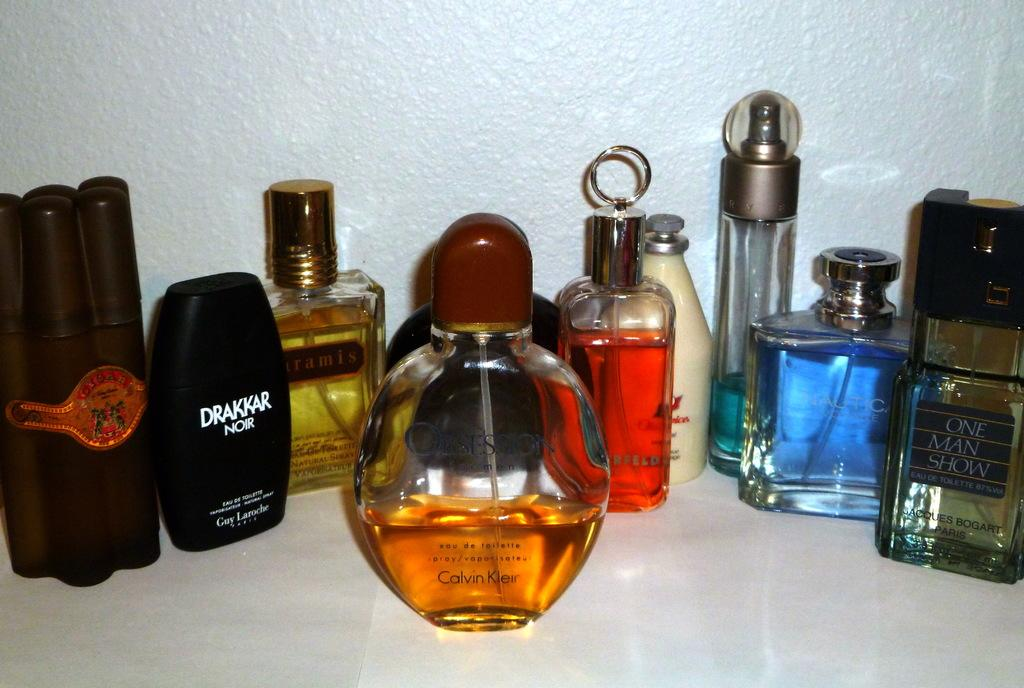What objects are in the image? There is a group of scent bottles in the image. Where are the scent bottles located? The scent bottles are on a table. What type of discussion is taking place between the rabbits in the image? There are no rabbits present in the image, so there cannot be a discussion between them. 